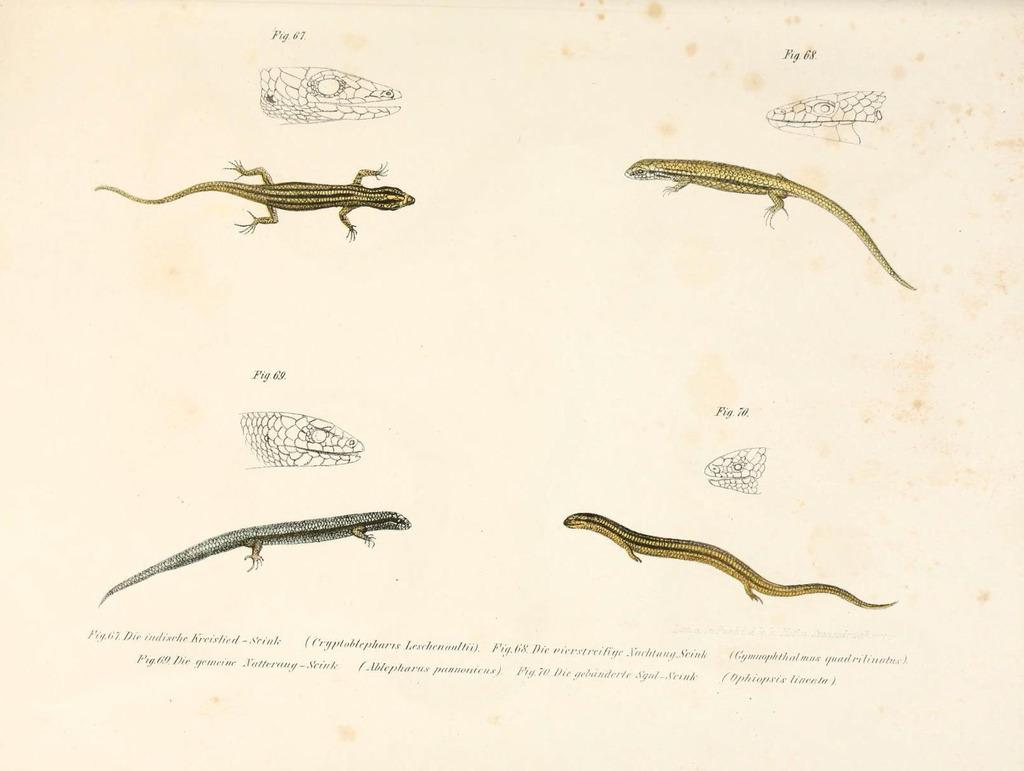How many different types of reptiles are present in the image? There are four different types of reptiles in the image. What is the story behind the crowd of people gathered around the reptiles in the image? There is no crowd of people or story present in the image; it only features four different types of reptiles. 